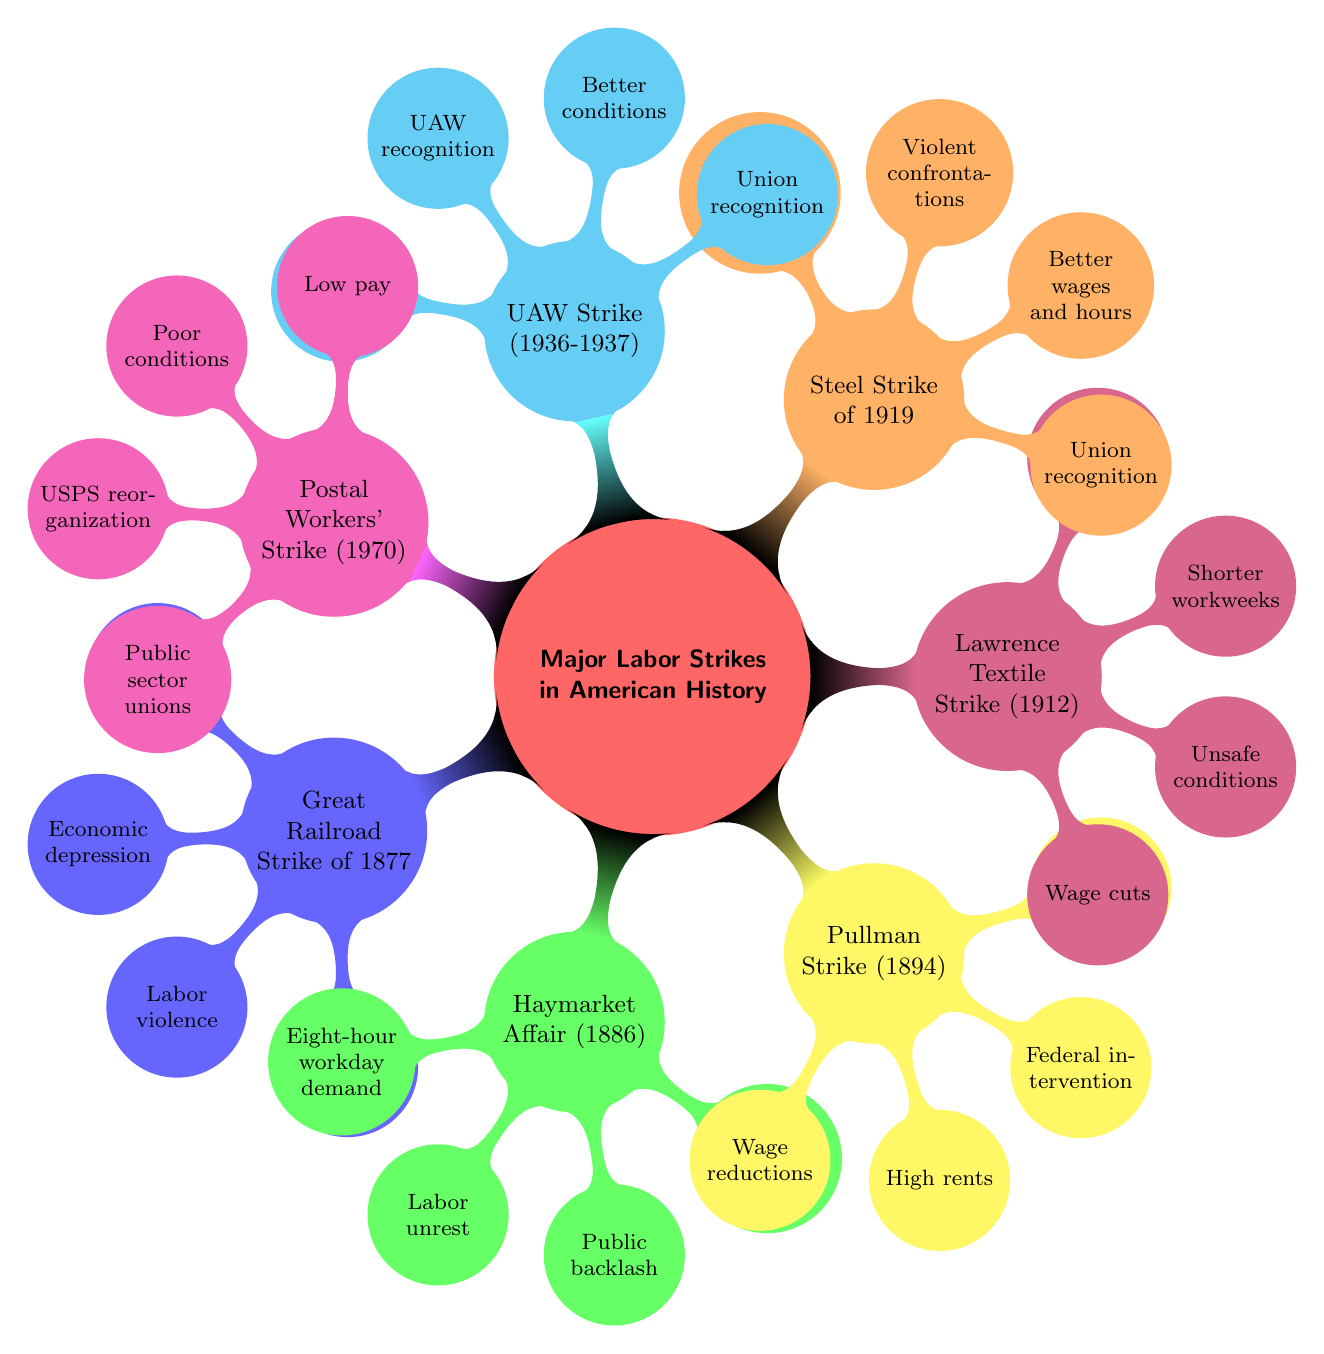What was a cause of the Great Railroad Strike of 1877? The diagram indicates "Wage cuts" and "Economic depression" as causes listed under the Great Railroad Strike of 1877. Since we are looking for a specific cause, "Wage cuts" is a direct answer as it appears first in both the list of causes.
Answer: Wage cuts What impact did the Pullman Strike of 1894 have? According to the diagram, "Federal intervention" and "Debs' imprisonment" are listed as impacts of the Pullman Strike of 1894. Either could be a valid answer, but choosing one, "Federal intervention" is a significant consequence that shows government involvement.
Answer: Federal intervention How many major labor strikes are listed in the diagram? By counting the main nodes branching from "Major Labor Strikes in American History," there are seven key strikes indicated in the diagram.
Answer: 7 Which strike focused on demands for an eight-hour workday? The diagram shows that the Haymarket Affair (1886) had "Demand for eight-hour workday" as one of its causes. Hence, it directly answers the question regarding which strike emphasized this demand.
Answer: Haymarket Affair (1886) What was a cause common to both the Steel Strike of 1919 and the UAW Strike (1936-1937)? The UAW Strike (1936-1937) and the Steel Strike of 1919 both mention "Demand for union recognition" as a key cause according to the diagram. Thus, they share this particular cause.
Answer: Demand for union recognition How did the Lawrence Textile Strike of 1912 influence labor legislation? The diagram states that one impact of the Lawrence Textile Strike (1912) was "Legislation for shorter workweeks," which indicates a direct influence on labor regulations following the strike.
Answer: Legislation for shorter workweeks What was a notable result of the Postal Workers' Strike of 1970? The outcome of the Postal Workers' Strike of 1970 included "Reorganization of USPS," showcasing significant administrative changes resulting from the event. This is a clear answer as depicted in the diagram.
Answer: Reorganization of USPS Which strike experienced violent confrontations as an impact? "Violent confrontations" is listed as an impact of the Steel Strike of 1919, indicating the severe nature of this event in terms of its consequences on labor relations.
Answer: Steel Strike of 1919 What unsafe conditions were cited in the 1912 Lawrence Textile Strike? The diagram indicates "Unsafe working conditions" as one of the causes of the Lawrence Textile Strike (1912), highlighting the perilous environment faced by workers, which serves as a specific answer.
Answer: Unsafe working conditions 